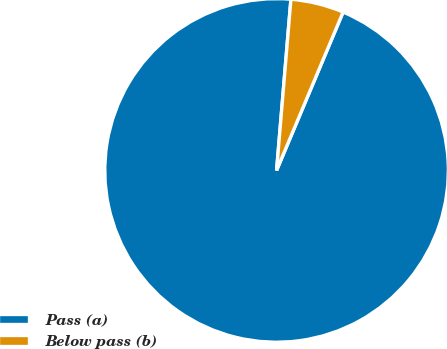Convert chart to OTSL. <chart><loc_0><loc_0><loc_500><loc_500><pie_chart><fcel>Pass (a)<fcel>Below pass (b)<nl><fcel>95.0%<fcel>5.0%<nl></chart> 